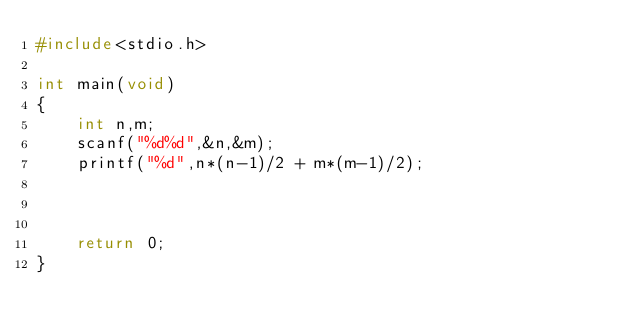<code> <loc_0><loc_0><loc_500><loc_500><_C_>#include<stdio.h>

int main(void)
{
    int n,m;
    scanf("%d%d",&n,&m);
    printf("%d",n*(n-1)/2 + m*(m-1)/2);


    
    return 0;
}</code> 